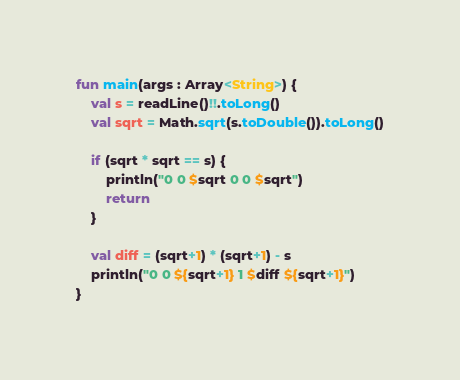<code> <loc_0><loc_0><loc_500><loc_500><_Kotlin_>fun main(args : Array<String>) {
    val s = readLine()!!.toLong()
    val sqrt = Math.sqrt(s.toDouble()).toLong()

    if (sqrt * sqrt == s) {
        println("0 0 $sqrt 0 0 $sqrt")
        return
    }

    val diff = (sqrt+1) * (sqrt+1) - s
    println("0 0 ${sqrt+1} 1 $diff ${sqrt+1}")
}</code> 